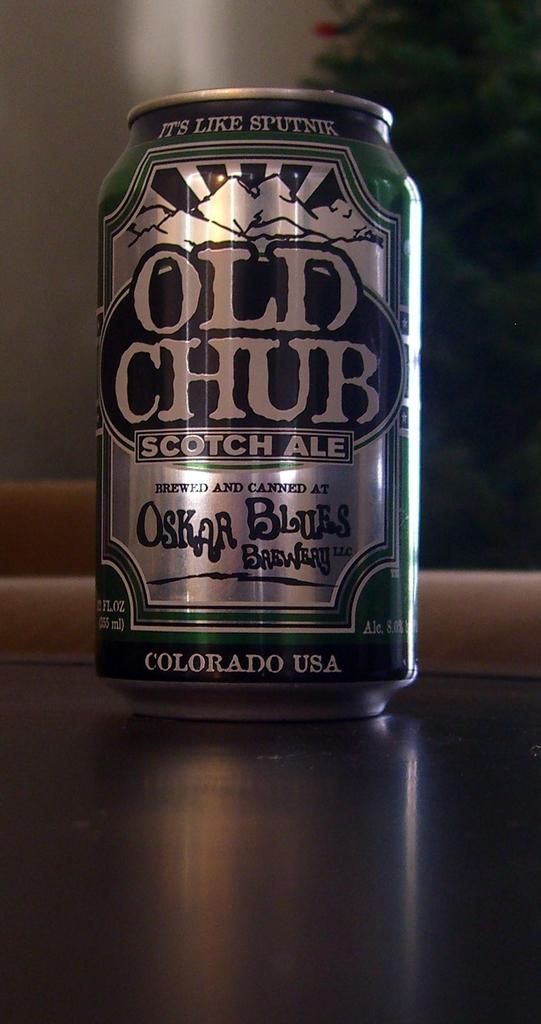Where was this drink made?
Make the answer very short. Colorado. What kind of ale?
Provide a succinct answer. Scotch. 